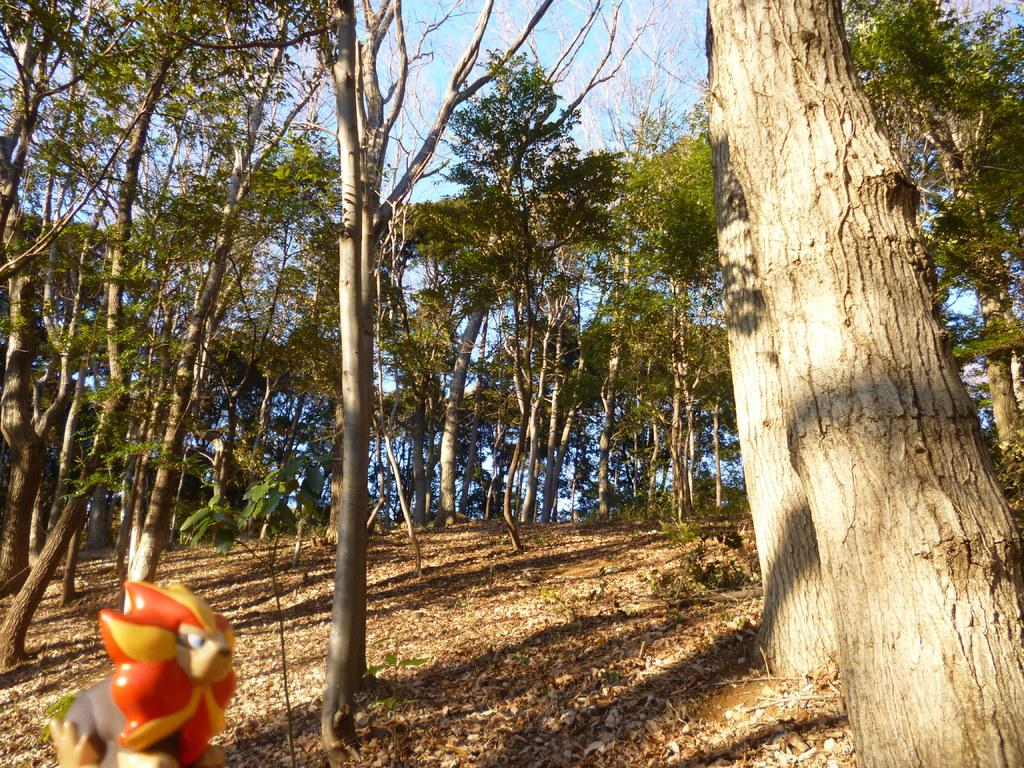What type of vegetation can be seen in the image? There are trees in the image. Where is the toy located in the image? The toy is in the bottom left corner of the image. What is covering the ground in the image? The ground is covered with dry leaves. What type of sofa can be seen in the image? There is no sofa present in the image. What selection of items is available for purchase in the image? The image does not depict any items for purchase, so it is not possible to determine a selection. 